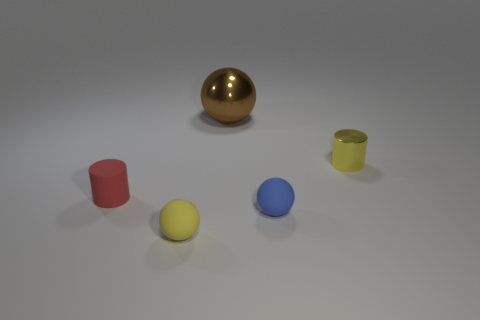What color is the metal object that is the same size as the red matte cylinder?
Your answer should be very brief. Yellow. Is the number of metal balls that are in front of the shiny sphere the same as the number of matte spheres?
Offer a very short reply. No. What is the shape of the object that is in front of the tiny red rubber cylinder and on the left side of the big brown metallic object?
Provide a succinct answer. Sphere. Is the yellow rubber ball the same size as the blue rubber object?
Give a very brief answer. Yes. Are there any red cylinders that have the same material as the blue thing?
Your response must be concise. Yes. There is another object that is the same color as the small metallic thing; what size is it?
Your answer should be very brief. Small. What number of metallic objects are both left of the tiny yellow metal cylinder and in front of the brown object?
Provide a short and direct response. 0. There is a yellow ball that is to the left of the big metal ball; what is it made of?
Your answer should be very brief. Rubber. How many matte balls are the same color as the small metallic object?
Provide a succinct answer. 1. There is a yellow cylinder that is the same material as the large ball; what is its size?
Ensure brevity in your answer.  Small. 